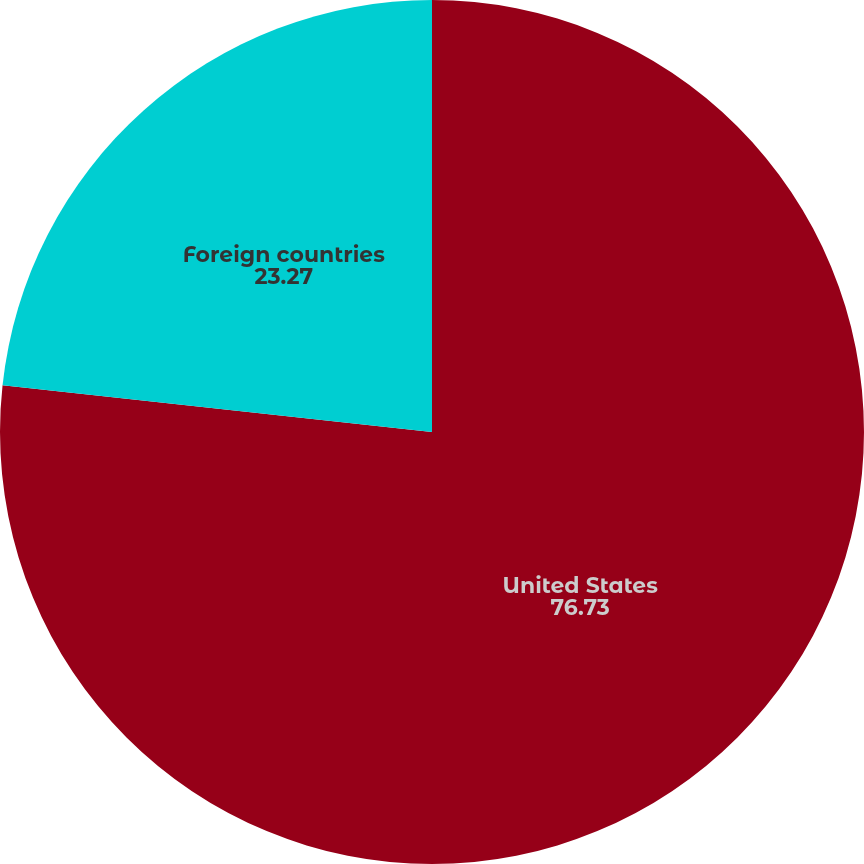Convert chart. <chart><loc_0><loc_0><loc_500><loc_500><pie_chart><fcel>United States<fcel>Foreign countries<nl><fcel>76.73%<fcel>23.27%<nl></chart> 